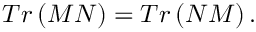<formula> <loc_0><loc_0><loc_500><loc_500>T r \left ( M N \right ) = T r \left ( N M \right ) .</formula> 